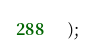Convert code to text. <code><loc_0><loc_0><loc_500><loc_500><_SQL_>);</code> 